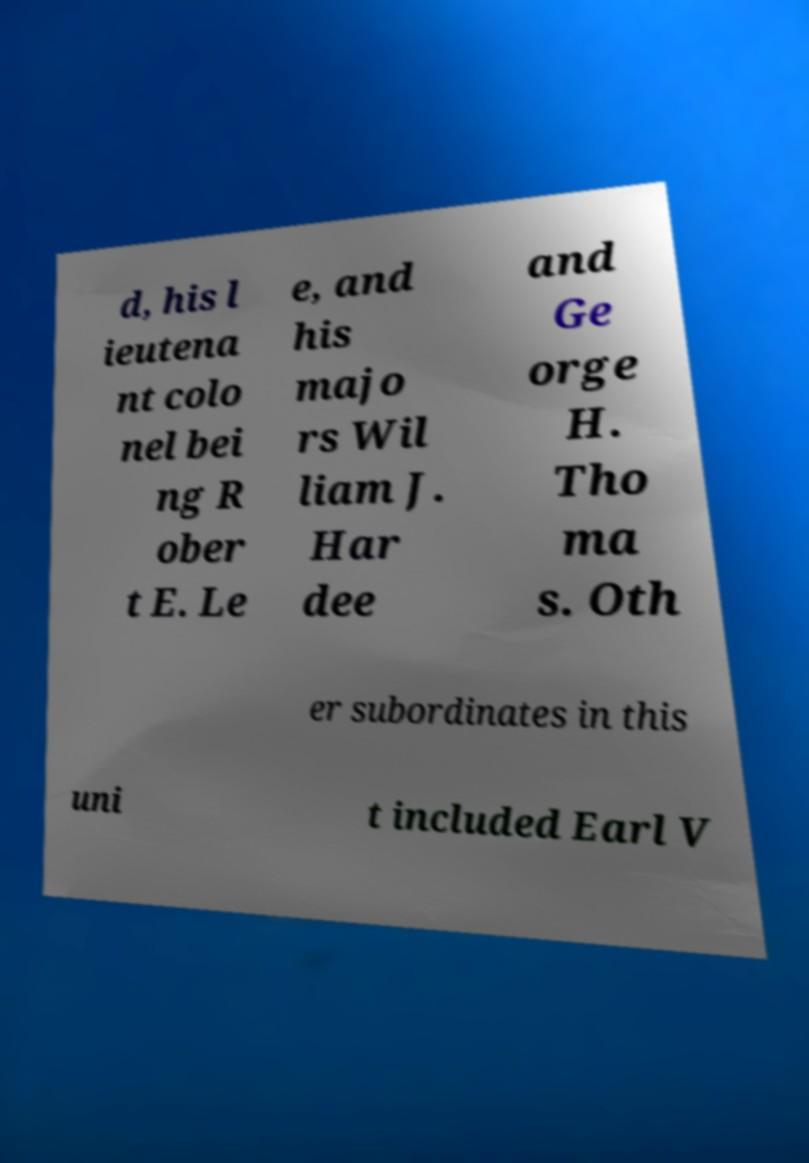Could you extract and type out the text from this image? d, his l ieutena nt colo nel bei ng R ober t E. Le e, and his majo rs Wil liam J. Har dee and Ge orge H. Tho ma s. Oth er subordinates in this uni t included Earl V 